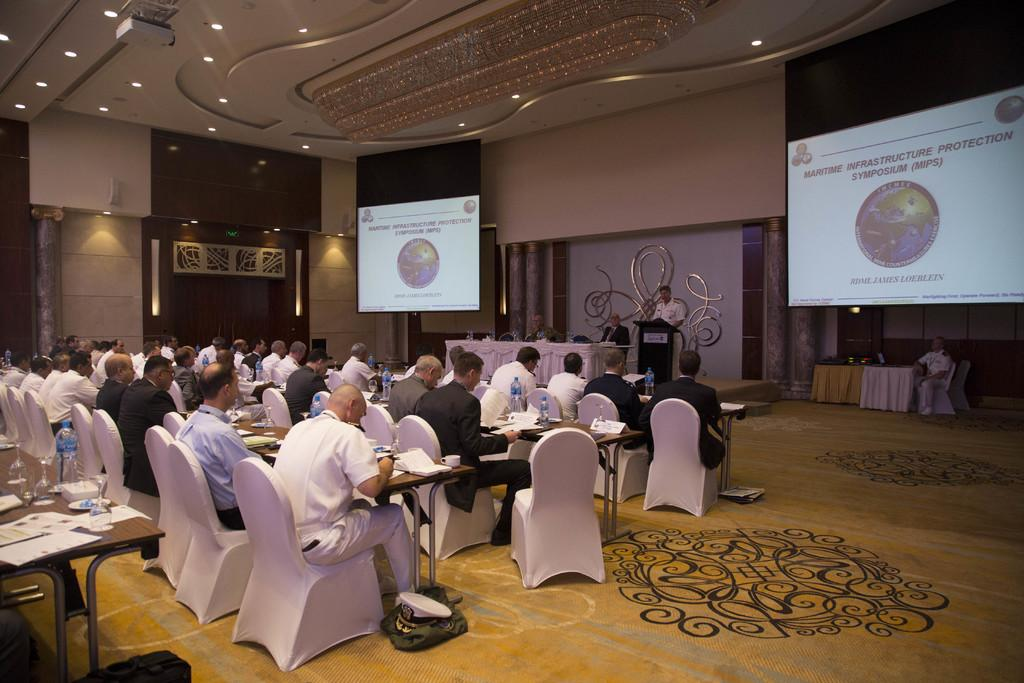What is one of the main features of the image? There is a wall in the image. What objects are present on the wall? There are two screens in the image. What are the people in the image doing? There are people sitting on chairs in the image. What type of furniture is present in the image? There are tables in the image. What items can be found on the tables? Papers, bottles, glasses, and books are present on the tables. How many horses are visible in the image? There are no horses present in the image. What type of zipper can be seen on the books in the image? There are no zippers on the books in the image; they are not mentioned in the provided facts. 